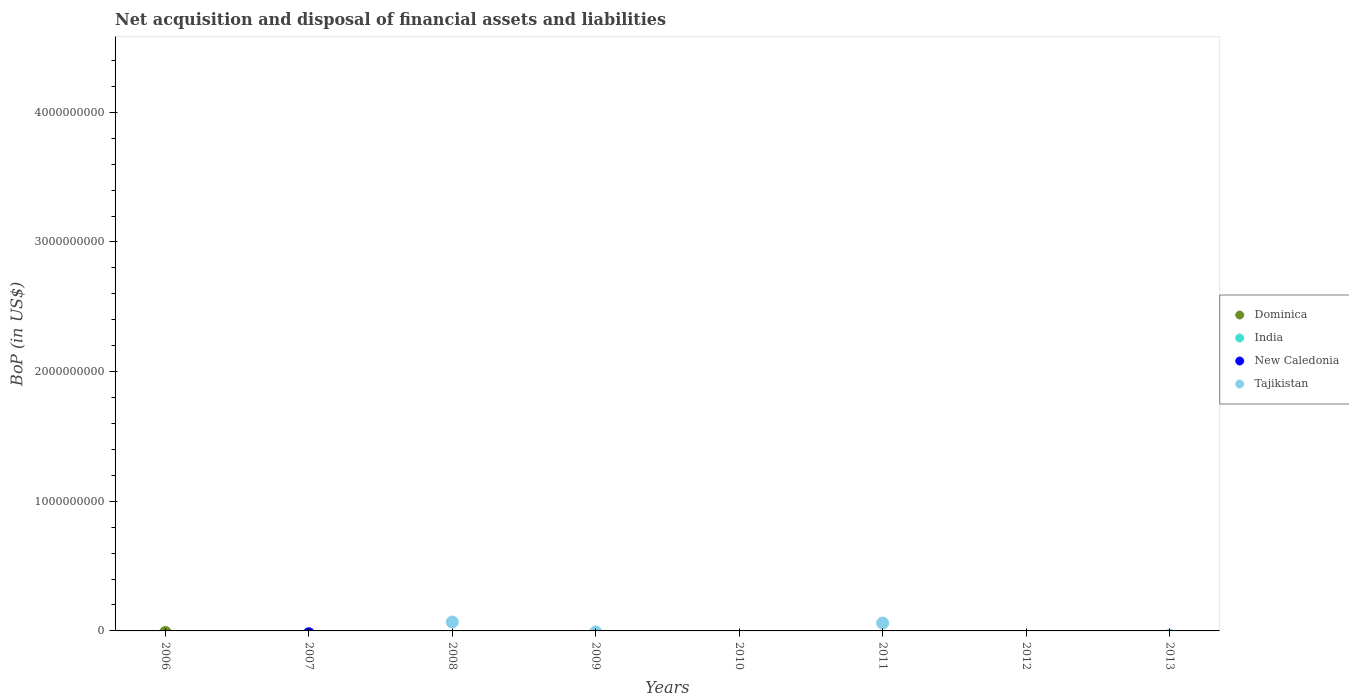How many different coloured dotlines are there?
Provide a short and direct response. 1. Is the number of dotlines equal to the number of legend labels?
Offer a terse response. No. What is the Balance of Payments in New Caledonia in 2009?
Your answer should be very brief. 0. Across all years, what is the maximum Balance of Payments in Tajikistan?
Provide a succinct answer. 6.87e+07. Across all years, what is the minimum Balance of Payments in Tajikistan?
Give a very brief answer. 0. In which year was the Balance of Payments in Tajikistan maximum?
Make the answer very short. 2008. What is the difference between the Balance of Payments in India in 2013 and the Balance of Payments in Tajikistan in 2012?
Provide a succinct answer. 0. Is it the case that in every year, the sum of the Balance of Payments in Tajikistan and Balance of Payments in New Caledonia  is greater than the sum of Balance of Payments in India and Balance of Payments in Dominica?
Your answer should be compact. No. Is it the case that in every year, the sum of the Balance of Payments in New Caledonia and Balance of Payments in Tajikistan  is greater than the Balance of Payments in Dominica?
Provide a short and direct response. No. Does the Balance of Payments in New Caledonia monotonically increase over the years?
Give a very brief answer. No. Is the Balance of Payments in India strictly less than the Balance of Payments in Tajikistan over the years?
Provide a succinct answer. Yes. How many years are there in the graph?
Give a very brief answer. 8. What is the difference between two consecutive major ticks on the Y-axis?
Your response must be concise. 1.00e+09. Are the values on the major ticks of Y-axis written in scientific E-notation?
Give a very brief answer. No. Does the graph contain grids?
Keep it short and to the point. No. Where does the legend appear in the graph?
Keep it short and to the point. Center right. How are the legend labels stacked?
Make the answer very short. Vertical. What is the title of the graph?
Give a very brief answer. Net acquisition and disposal of financial assets and liabilities. What is the label or title of the X-axis?
Your answer should be very brief. Years. What is the label or title of the Y-axis?
Ensure brevity in your answer.  BoP (in US$). What is the BoP (in US$) in Tajikistan in 2006?
Your response must be concise. 0. What is the BoP (in US$) in India in 2007?
Provide a short and direct response. 0. What is the BoP (in US$) in New Caledonia in 2007?
Your answer should be compact. 0. What is the BoP (in US$) in India in 2008?
Provide a succinct answer. 0. What is the BoP (in US$) in New Caledonia in 2008?
Provide a short and direct response. 0. What is the BoP (in US$) of Tajikistan in 2008?
Provide a succinct answer. 6.87e+07. What is the BoP (in US$) of India in 2009?
Keep it short and to the point. 0. What is the BoP (in US$) in Dominica in 2010?
Make the answer very short. 0. What is the BoP (in US$) of New Caledonia in 2010?
Give a very brief answer. 0. What is the BoP (in US$) of Tajikistan in 2010?
Make the answer very short. 0. What is the BoP (in US$) of Dominica in 2011?
Provide a short and direct response. 0. What is the BoP (in US$) in India in 2011?
Offer a terse response. 0. What is the BoP (in US$) of New Caledonia in 2011?
Make the answer very short. 0. What is the BoP (in US$) in Tajikistan in 2011?
Provide a short and direct response. 6.09e+07. What is the BoP (in US$) of New Caledonia in 2012?
Your response must be concise. 0. What is the BoP (in US$) of Dominica in 2013?
Make the answer very short. 0. What is the BoP (in US$) of India in 2013?
Keep it short and to the point. 0. What is the BoP (in US$) in Tajikistan in 2013?
Give a very brief answer. 0. Across all years, what is the maximum BoP (in US$) of Tajikistan?
Your answer should be very brief. 6.87e+07. Across all years, what is the minimum BoP (in US$) of Tajikistan?
Your answer should be compact. 0. What is the total BoP (in US$) in Dominica in the graph?
Provide a succinct answer. 0. What is the total BoP (in US$) of India in the graph?
Provide a succinct answer. 0. What is the total BoP (in US$) of Tajikistan in the graph?
Keep it short and to the point. 1.30e+08. What is the difference between the BoP (in US$) in Tajikistan in 2008 and that in 2011?
Your answer should be very brief. 7.79e+06. What is the average BoP (in US$) in Dominica per year?
Your response must be concise. 0. What is the average BoP (in US$) in New Caledonia per year?
Your answer should be very brief. 0. What is the average BoP (in US$) of Tajikistan per year?
Keep it short and to the point. 1.62e+07. What is the ratio of the BoP (in US$) of Tajikistan in 2008 to that in 2011?
Ensure brevity in your answer.  1.13. What is the difference between the highest and the lowest BoP (in US$) in Tajikistan?
Your response must be concise. 6.87e+07. 